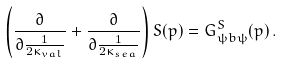<formula> <loc_0><loc_0><loc_500><loc_500>\left ( \frac { \partial } { \partial { \frac { 1 } { 2 \kappa _ { v a l } } } } + \frac { \partial } { \partial { \frac { 1 } { 2 \kappa _ { s e a } } } } \right ) S ( p ) = G ^ { S } _ { \psi b \psi } ( p ) \, .</formula> 